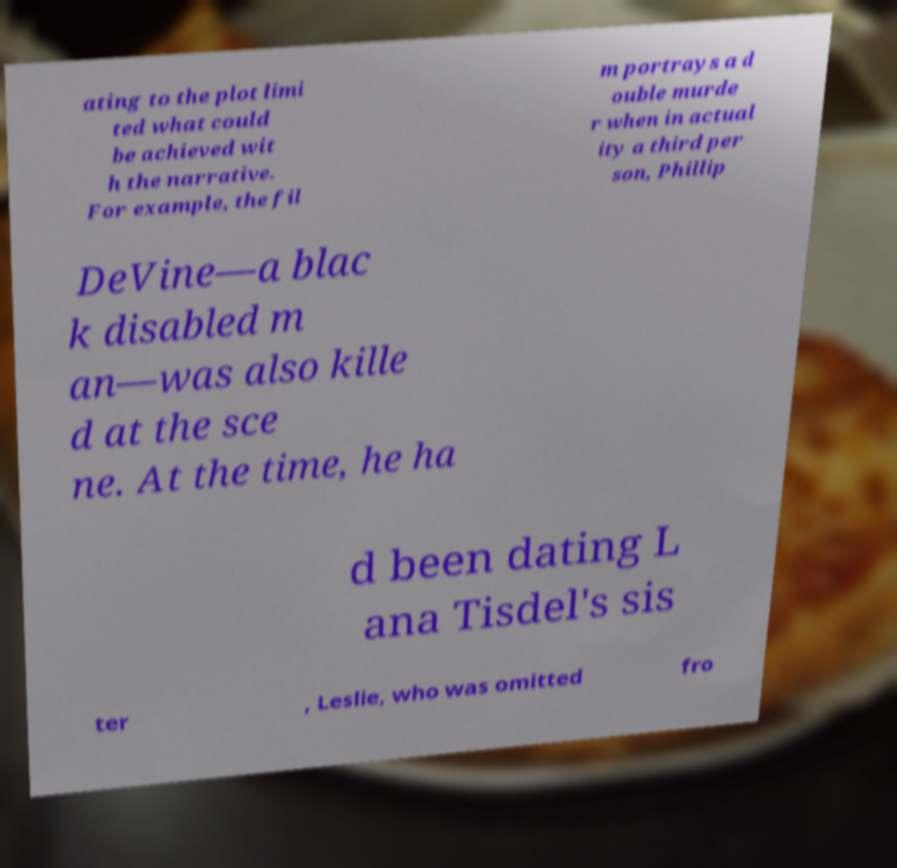Could you assist in decoding the text presented in this image and type it out clearly? ating to the plot limi ted what could be achieved wit h the narrative. For example, the fil m portrays a d ouble murde r when in actual ity a third per son, Phillip DeVine—a blac k disabled m an—was also kille d at the sce ne. At the time, he ha d been dating L ana Tisdel's sis ter , Leslie, who was omitted fro 